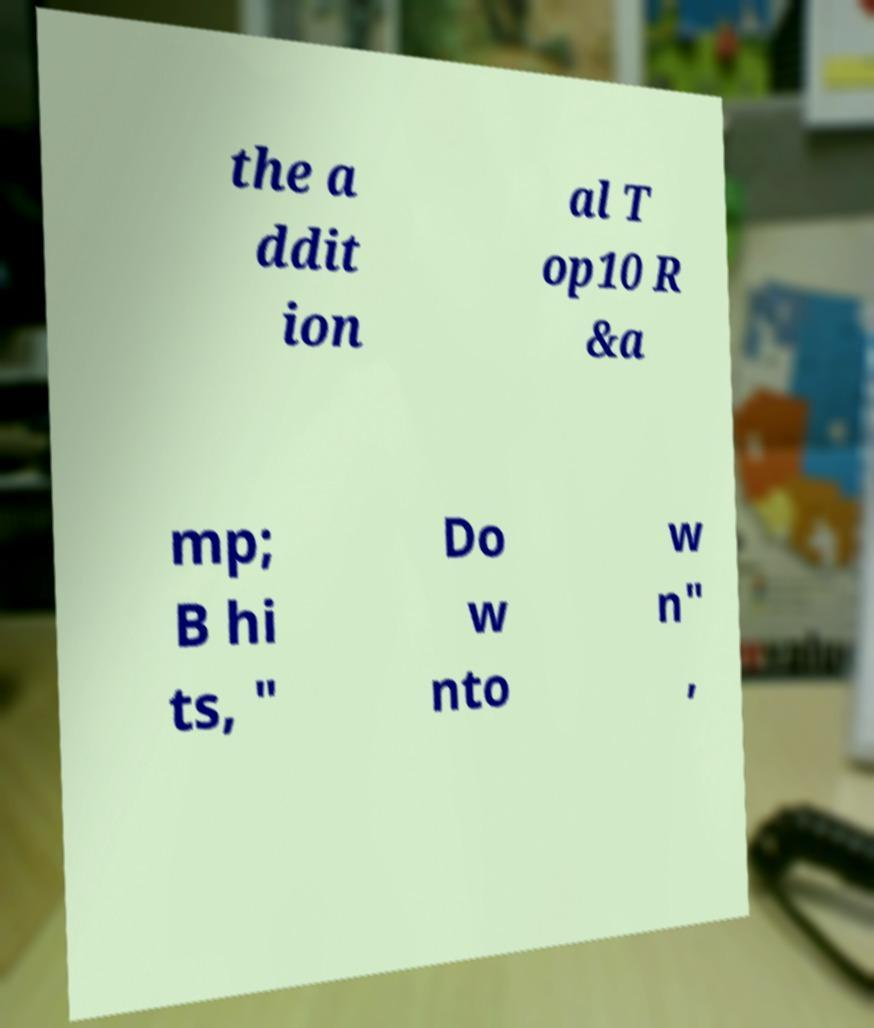Could you assist in decoding the text presented in this image and type it out clearly? the a ddit ion al T op10 R &a mp; B hi ts, " Do w nto w n" , 